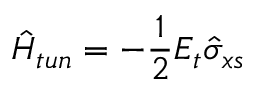Convert formula to latex. <formula><loc_0><loc_0><loc_500><loc_500>\hat { H } _ { t u n } = - \frac { 1 } { 2 } E _ { t } \hat { \sigma } _ { x s }</formula> 